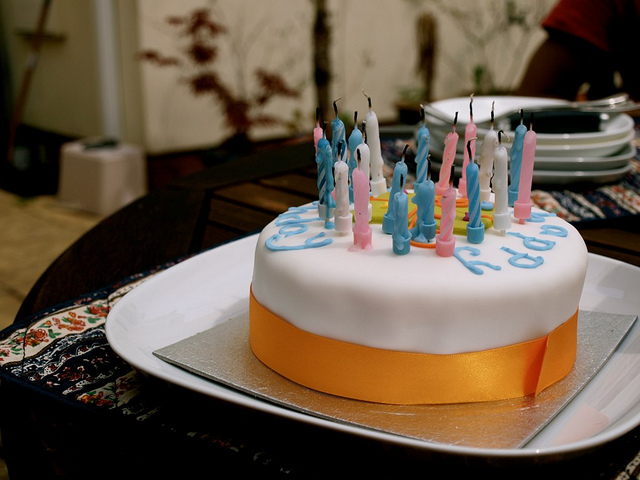<image>What is the name on the side of the cake? The name on the side of the cake is not visible. What is the name on the side of the cake? The name on the side of the cake is not visible. 